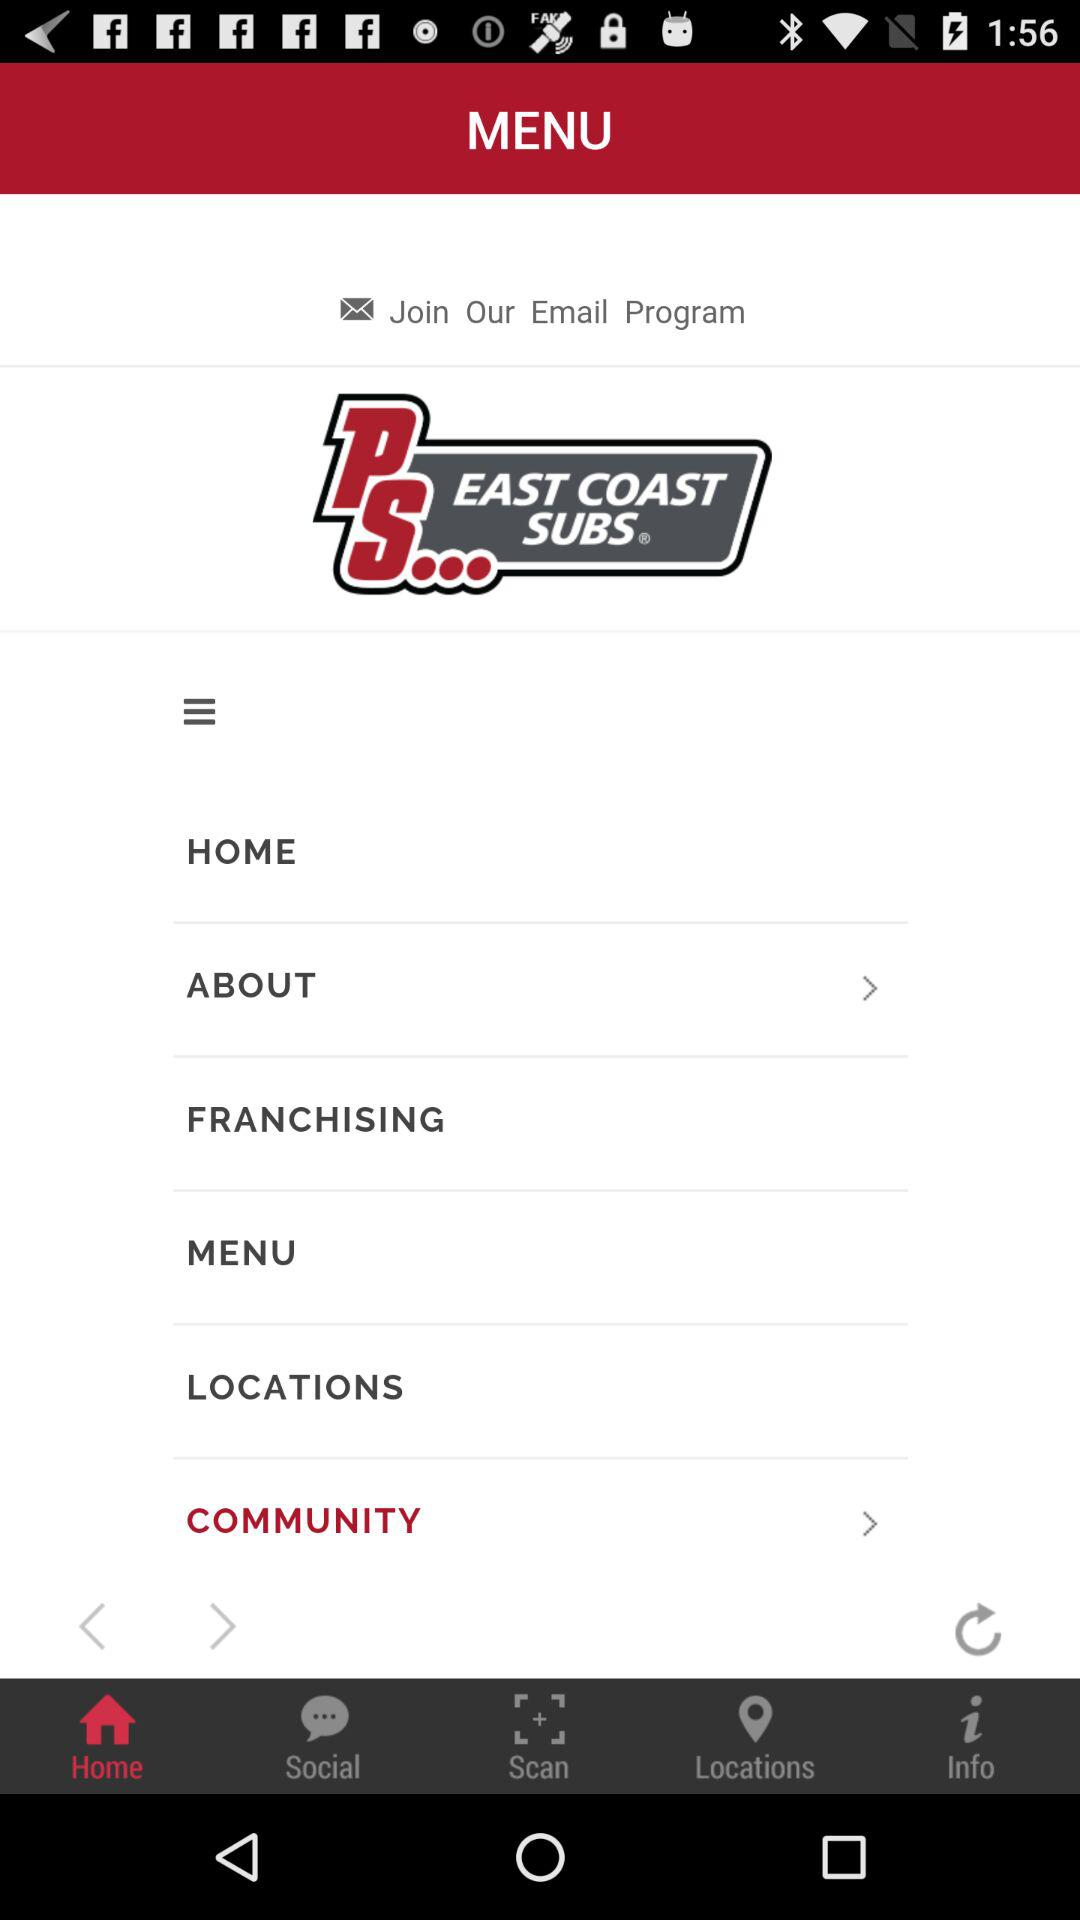Which tab am I on? You are on the "Home" tab. 